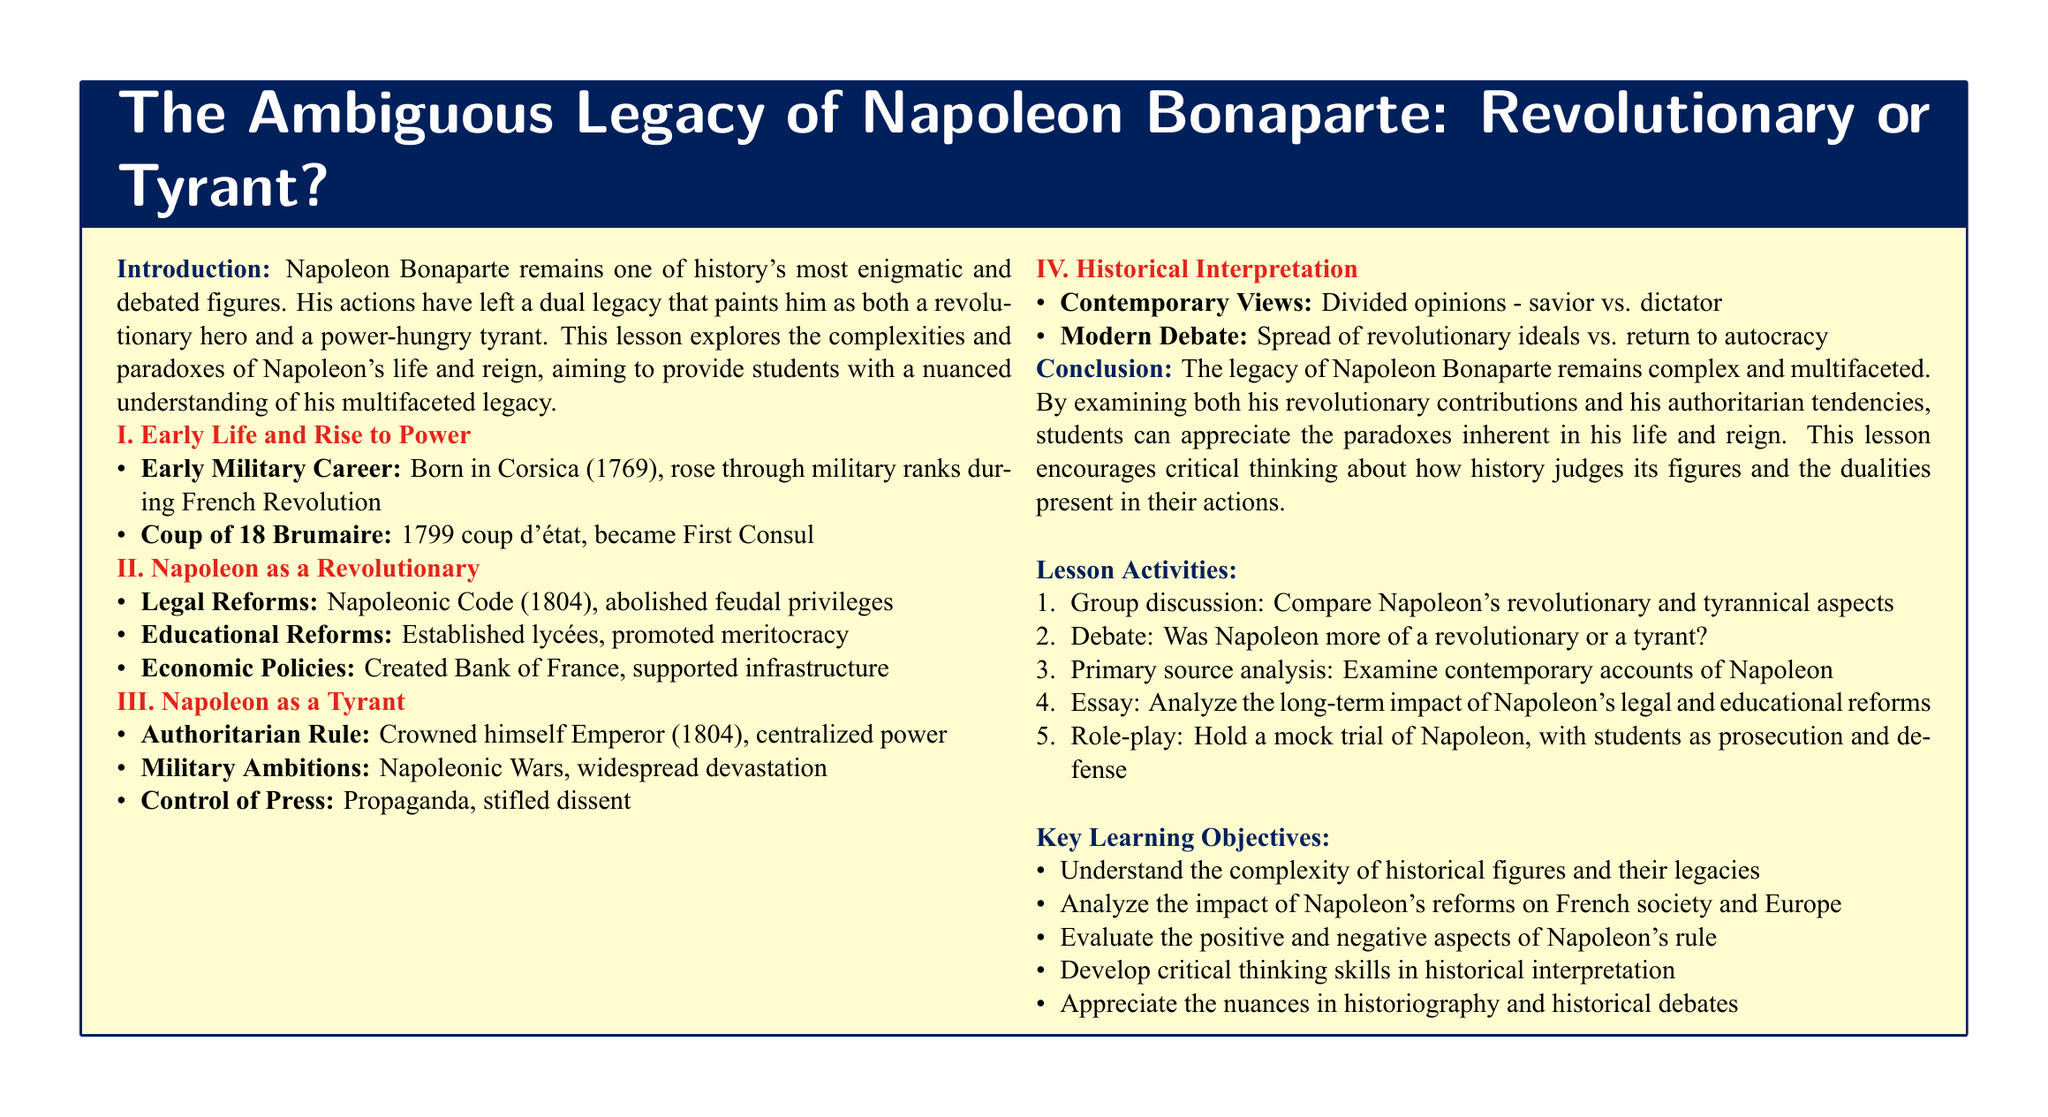What year was Napoleon born? The document states that Napoleon Bonaparte was born in Corsica in 1769.
Answer: 1769 What was the name of the legal reforms Napoleon introduced? The document mentions that Napoleon established the Napoleonic Code in 1804.
Answer: Napoleonic Code What significant title did Napoleon crown himself with in 1804? According to the document, Napoleon crowned himself as Emperor in 1804.
Answer: Emperor What was one key aspect of Napoleon's educational reforms? The document lists that he established lycées and promoted meritocracy as part of his educational reforms.
Answer: Established lycées What were the different contemporary views on Napoleon mentioned in the lesson? The document references that contemporary views divide between seeing him as a savior or a dictator.
Answer: Savior vs. dictator What is one conclusion drawn about Napoleon's legacy in the lesson? The document concludes that Napoleon's legacy remains complex and multifaceted due to his dual contributions.
Answer: Complex and multifaceted How many key learning objectives are listed in the document? The lesson plan enumerates five key learning objectives in the document.
Answer: Five What is the main focus of the group discussion activity? The document specifies that the group discussion activity focuses on comparing Napoleon's revolutionary and tyrannical aspects.
Answer: Compare revolutionary and tyrannical aspects What significant event marked Napoleon's rise to power? The document mentions the Coup of 18 Brumaire as the event that marked Napoleon's rise to power.
Answer: Coup of 18 Brumaire 